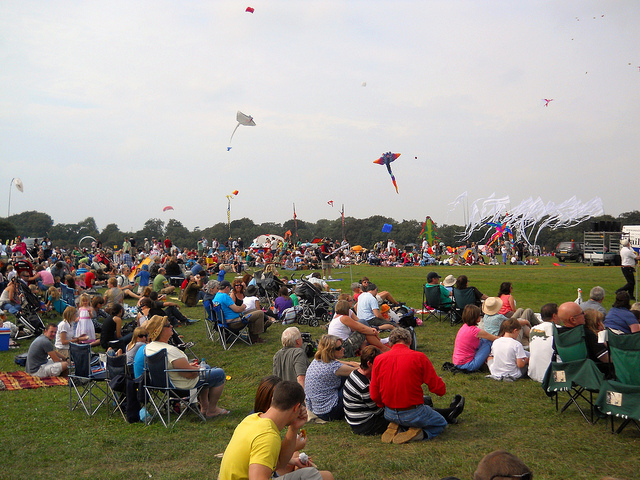What type toys unite these people today? The people gathered here are united by their shared enjoyment of kites, which dot the sky above them. Although option B 'toys' is technically correct, 'kites' would be a more precise answer, as they are the specific type of toy that has brought everyone together in this open field. 